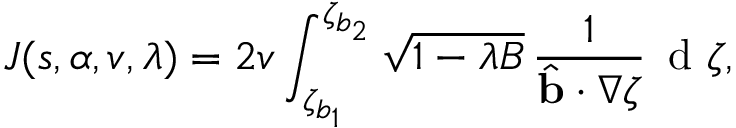Convert formula to latex. <formula><loc_0><loc_0><loc_500><loc_500>J ( s , \alpha , v , \lambda ) = 2 v \int _ { \zeta _ { b _ { 1 } } } ^ { \zeta _ { b _ { 2 } } } \sqrt { 1 - \lambda B } \, \frac { 1 } { \hat { b } \cdot \nabla \zeta } \, d \zeta ,</formula> 